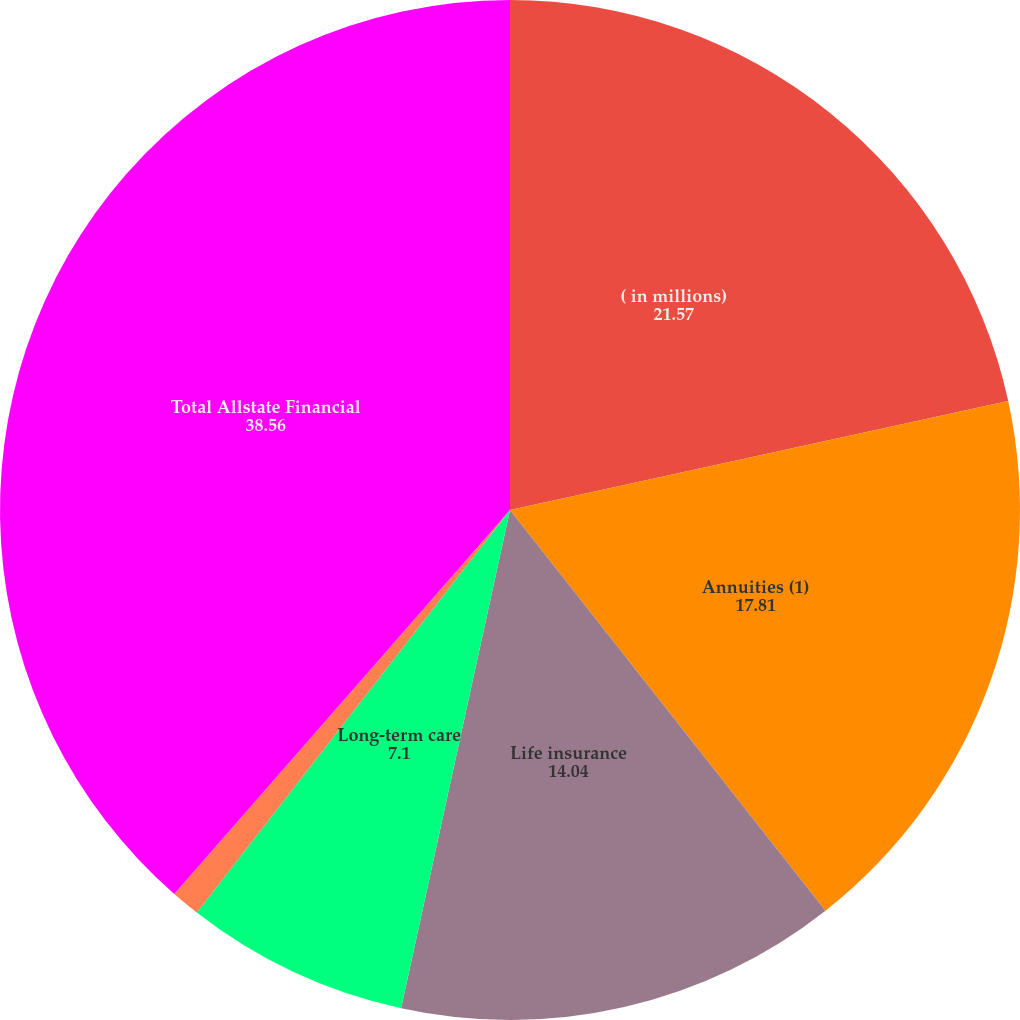Convert chart. <chart><loc_0><loc_0><loc_500><loc_500><pie_chart><fcel>( in millions)<fcel>Annuities (1)<fcel>Life insurance<fcel>Long-term care<fcel>Other<fcel>Total Allstate Financial<nl><fcel>21.57%<fcel>17.81%<fcel>14.04%<fcel>7.1%<fcel>0.91%<fcel>38.56%<nl></chart> 